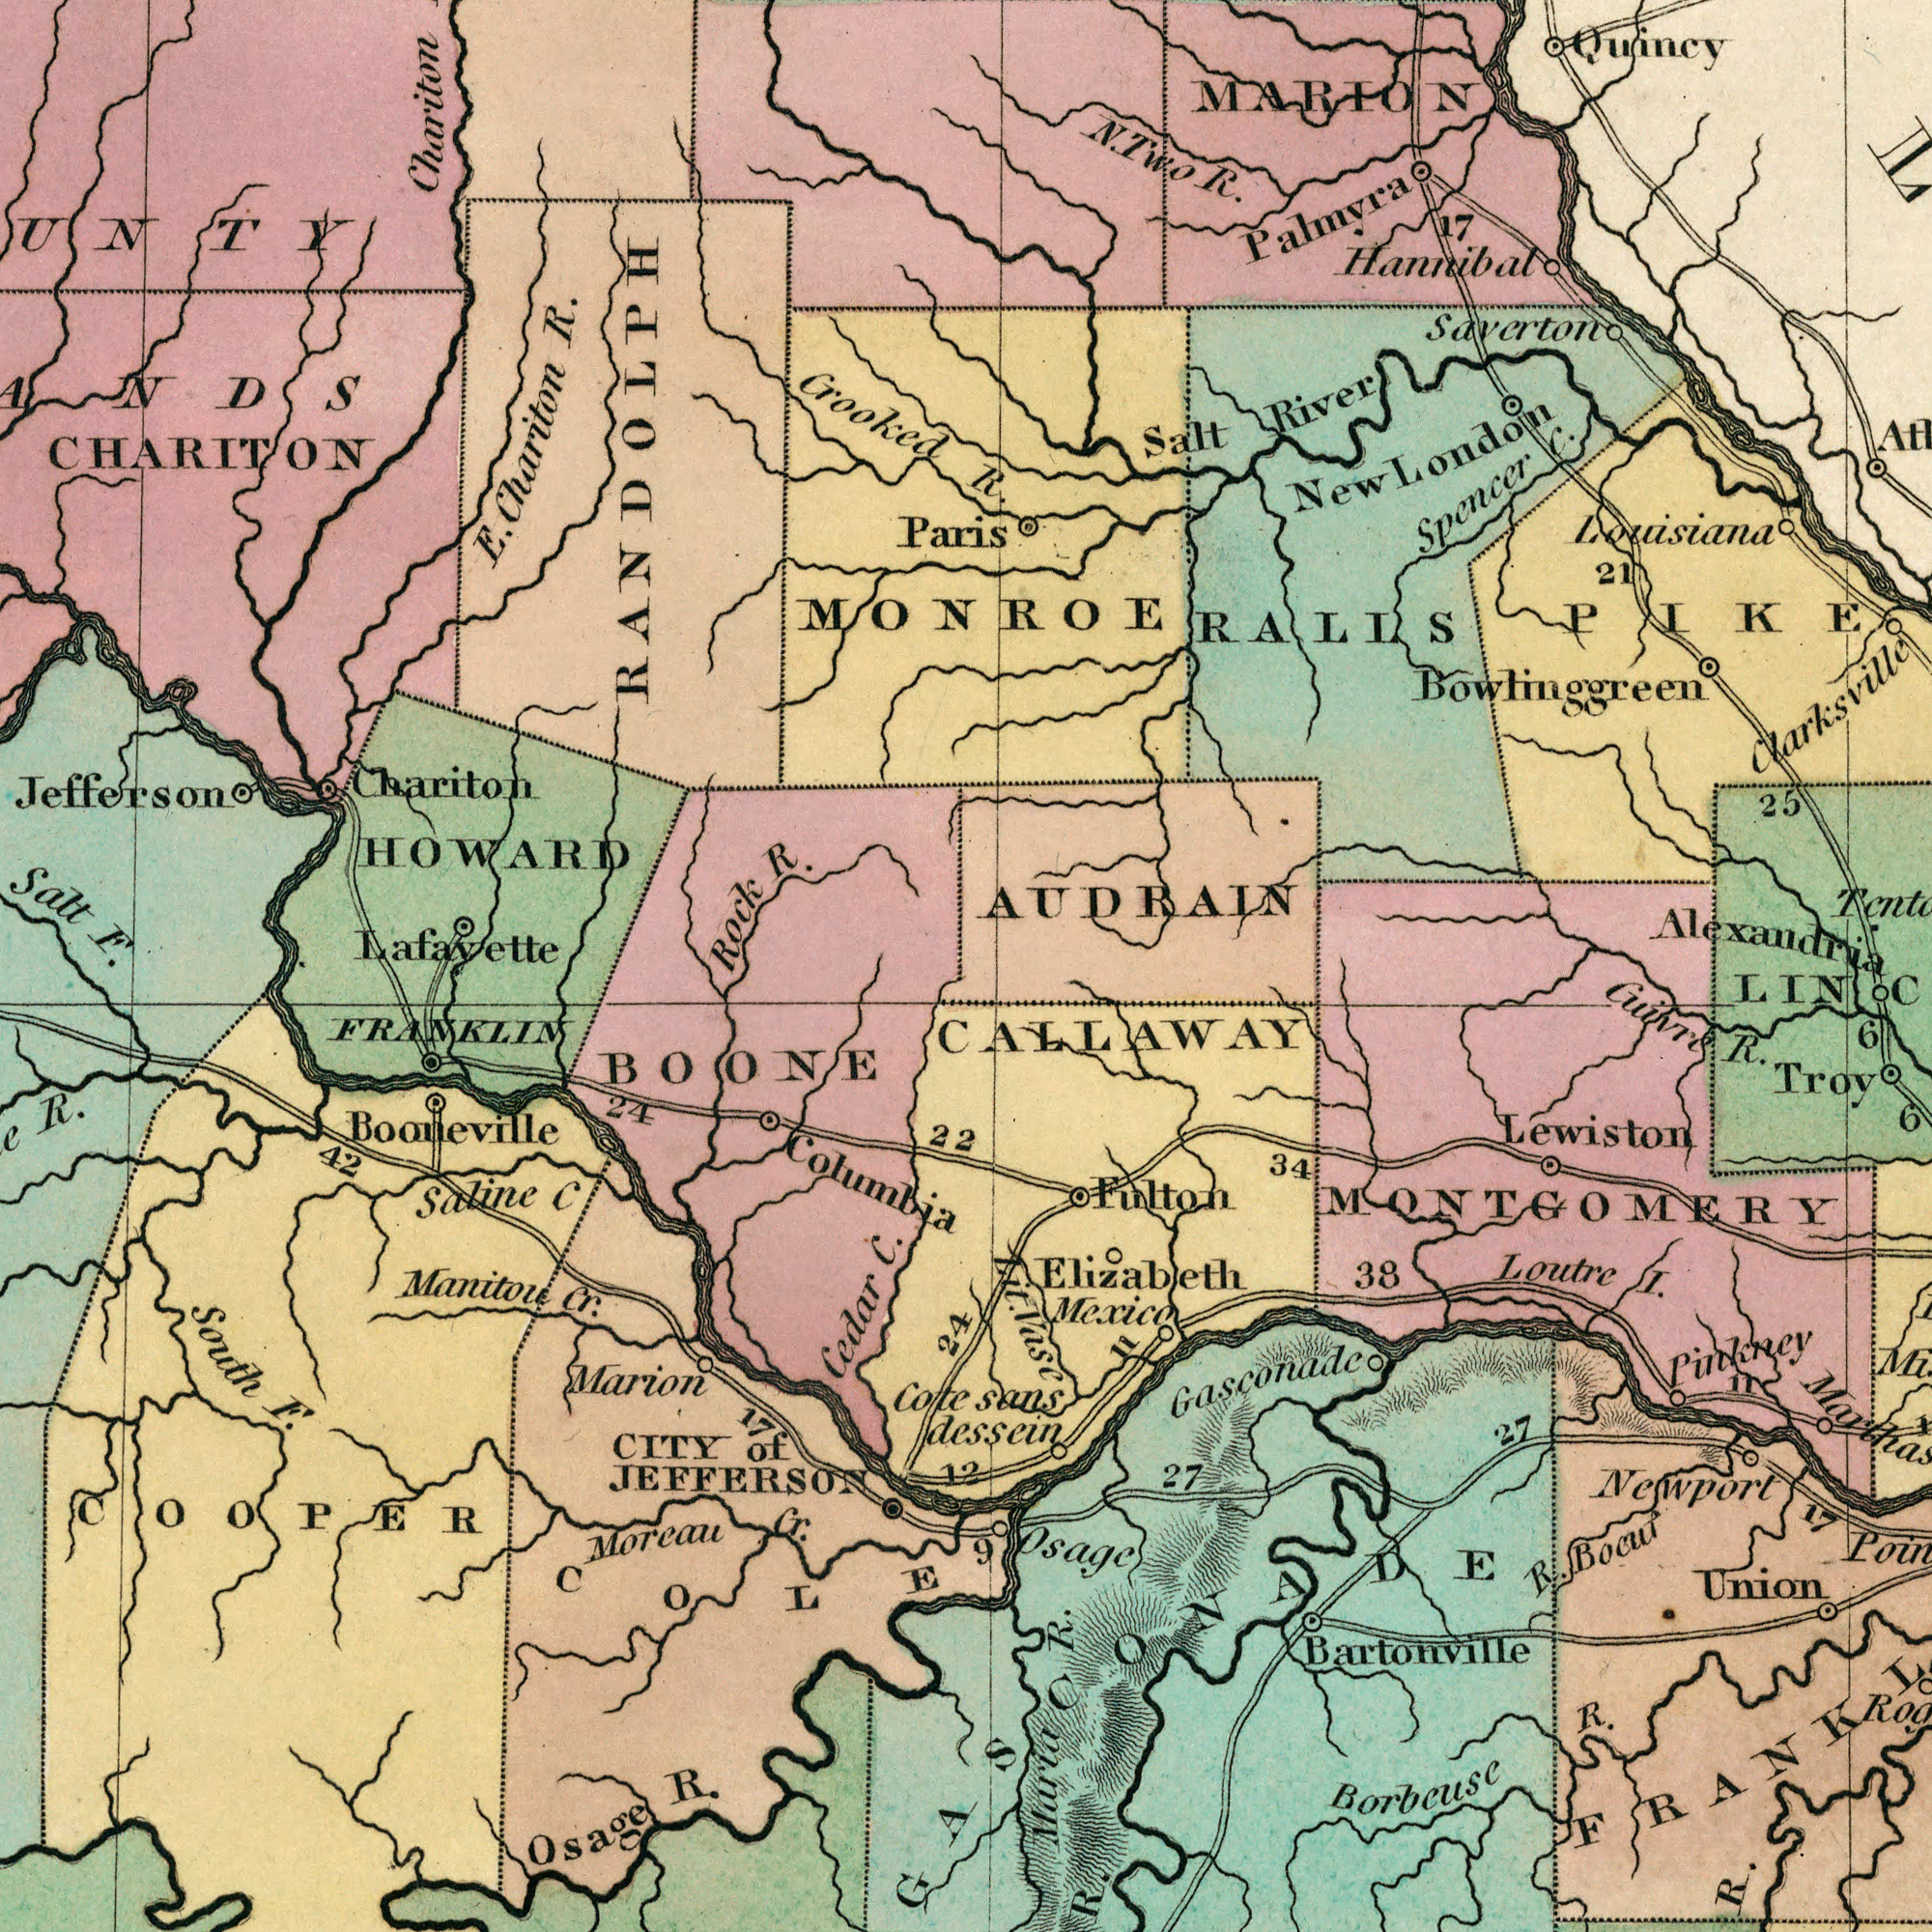What text can you see in the bottom-left section? JEFFERSON F. R. South Cedar Cr. Osage Manitou Moreau R. CITY Cote COOPER Cr. C. Saline C of COLE FRANKLIN Marion Columbia 42 24 BOONE 22 Booneville 17 24 12 What text can you see in the top-left section? R. R. Crooked Salt Chariton Rock E. F. CHARITON Chariton HOWARD Paris Jefferson RANDOLPH Chariton Lafayette What text can you see in the top-right section? Saverton River Spencer Quincy Salt Alexandria R. N. R. Two New London C. Hannibal Louisiana Clarksville 17 25 Bowlinggreen 21 MARION AUDRAIN Palmyra PIKE MONROE RALLS What text appears in the bottom-right area of the image? Newport Pinkney Borbcuse sans I. Loutre R. LIN dessein R. Maria R. Bocuf Vase Lit. R. Cuivre R. Mexico Osage 38 Bartonville 34 27 Fulton 6 17 R. CALLAWAY Union 9 27 Gasconade Elizabeth Lewiston 6 11 MONTGOMERY 11 Troy 